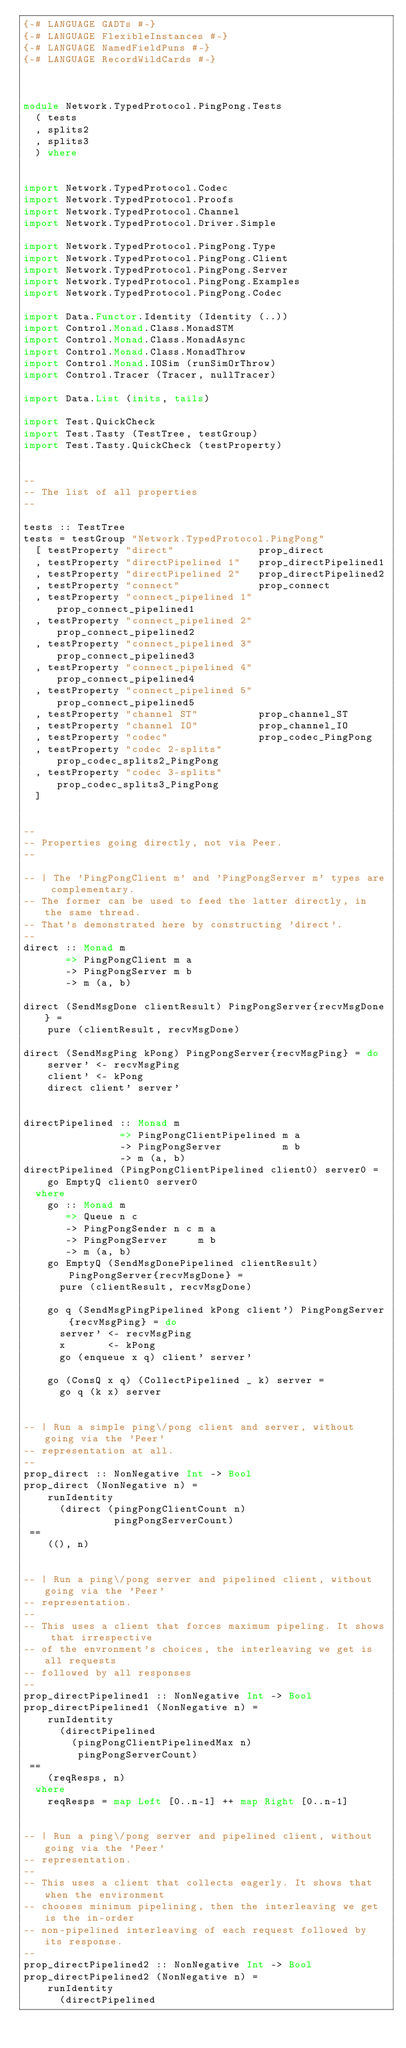Convert code to text. <code><loc_0><loc_0><loc_500><loc_500><_Haskell_>{-# LANGUAGE GADTs #-}
{-# LANGUAGE FlexibleInstances #-}
{-# LANGUAGE NamedFieldPuns #-}
{-# LANGUAGE RecordWildCards #-}



module Network.TypedProtocol.PingPong.Tests
  ( tests
  , splits2
  , splits3
  ) where


import Network.TypedProtocol.Codec
import Network.TypedProtocol.Proofs
import Network.TypedProtocol.Channel
import Network.TypedProtocol.Driver.Simple

import Network.TypedProtocol.PingPong.Type
import Network.TypedProtocol.PingPong.Client
import Network.TypedProtocol.PingPong.Server
import Network.TypedProtocol.PingPong.Examples
import Network.TypedProtocol.PingPong.Codec

import Data.Functor.Identity (Identity (..))
import Control.Monad.Class.MonadSTM
import Control.Monad.Class.MonadAsync
import Control.Monad.Class.MonadThrow
import Control.Monad.IOSim (runSimOrThrow)
import Control.Tracer (Tracer, nullTracer)

import Data.List (inits, tails)

import Test.QuickCheck
import Test.Tasty (TestTree, testGroup)
import Test.Tasty.QuickCheck (testProperty)


--
-- The list of all properties
--

tests :: TestTree
tests = testGroup "Network.TypedProtocol.PingPong"
  [ testProperty "direct"              prop_direct
  , testProperty "directPipelined 1"   prop_directPipelined1
  , testProperty "directPipelined 2"   prop_directPipelined2
  , testProperty "connect"             prop_connect
  , testProperty "connect_pipelined 1" prop_connect_pipelined1
  , testProperty "connect_pipelined 2" prop_connect_pipelined2
  , testProperty "connect_pipelined 3" prop_connect_pipelined3
  , testProperty "connect_pipelined 4" prop_connect_pipelined4
  , testProperty "connect_pipelined 5" prop_connect_pipelined5
  , testProperty "channel ST"          prop_channel_ST
  , testProperty "channel IO"          prop_channel_IO
  , testProperty "codec"               prop_codec_PingPong
  , testProperty "codec 2-splits"      prop_codec_splits2_PingPong
  , testProperty "codec 3-splits"      prop_codec_splits3_PingPong
  ]


--
-- Properties going directly, not via Peer.
--

-- | The 'PingPongClient m' and 'PingPongServer m' types are complementary.
-- The former can be used to feed the latter directly, in the same thread.
-- That's demonstrated here by constructing 'direct'.
--
direct :: Monad m
       => PingPongClient m a
       -> PingPongServer m b
       -> m (a, b)

direct (SendMsgDone clientResult) PingPongServer{recvMsgDone} =
    pure (clientResult, recvMsgDone)

direct (SendMsgPing kPong) PingPongServer{recvMsgPing} = do
    server' <- recvMsgPing
    client' <- kPong
    direct client' server'


directPipelined :: Monad m
                => PingPongClientPipelined m a
                -> PingPongServer          m b
                -> m (a, b)
directPipelined (PingPongClientPipelined client0) server0 =
    go EmptyQ client0 server0
  where
    go :: Monad m
       => Queue n c
       -> PingPongSender n c m a
       -> PingPongServer     m b
       -> m (a, b)
    go EmptyQ (SendMsgDonePipelined clientResult) PingPongServer{recvMsgDone} =
      pure (clientResult, recvMsgDone)

    go q (SendMsgPingPipelined kPong client') PingPongServer{recvMsgPing} = do
      server' <- recvMsgPing
      x       <- kPong
      go (enqueue x q) client' server'

    go (ConsQ x q) (CollectPipelined _ k) server =
      go q (k x) server


-- | Run a simple ping\/pong client and server, without going via the 'Peer'
-- representation at all.
--
prop_direct :: NonNegative Int -> Bool
prop_direct (NonNegative n) =
    runIdentity
      (direct (pingPongClientCount n)
               pingPongServerCount)
 ==
    ((), n)


-- | Run a ping\/pong server and pipelined client, without going via the 'Peer'
-- representation.
--
-- This uses a client that forces maximum pipeling. It shows that irrespective
-- of the envronment's choices, the interleaving we get is all requests
-- followed by all responses
--
prop_directPipelined1 :: NonNegative Int -> Bool
prop_directPipelined1 (NonNegative n) =
    runIdentity
      (directPipelined
        (pingPongClientPipelinedMax n)
         pingPongServerCount)
 ==
    (reqResps, n)
  where
    reqResps = map Left [0..n-1] ++ map Right [0..n-1]


-- | Run a ping\/pong server and pipelined client, without going via the 'Peer'
-- representation.
--
-- This uses a client that collects eagerly. It shows that when the environment
-- chooses minimum pipelining, then the interleaving we get is the in-order
-- non-pipelined interleaving of each request followed by its response.
--
prop_directPipelined2 :: NonNegative Int -> Bool
prop_directPipelined2 (NonNegative n) =
    runIdentity
      (directPipelined</code> 